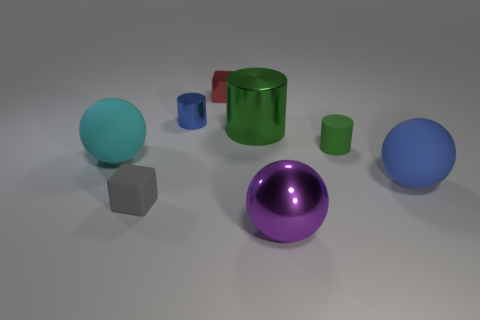What materials do the objects in the image seem to be made of? The objects in the image appear to be made of different materials. The spheres and cylinders have a reflective surface, suggesting they could be made of polished metal or plastic, while the cube appears to have a matte finish, which could be more indicative of a material like stone or unpolished metal. 